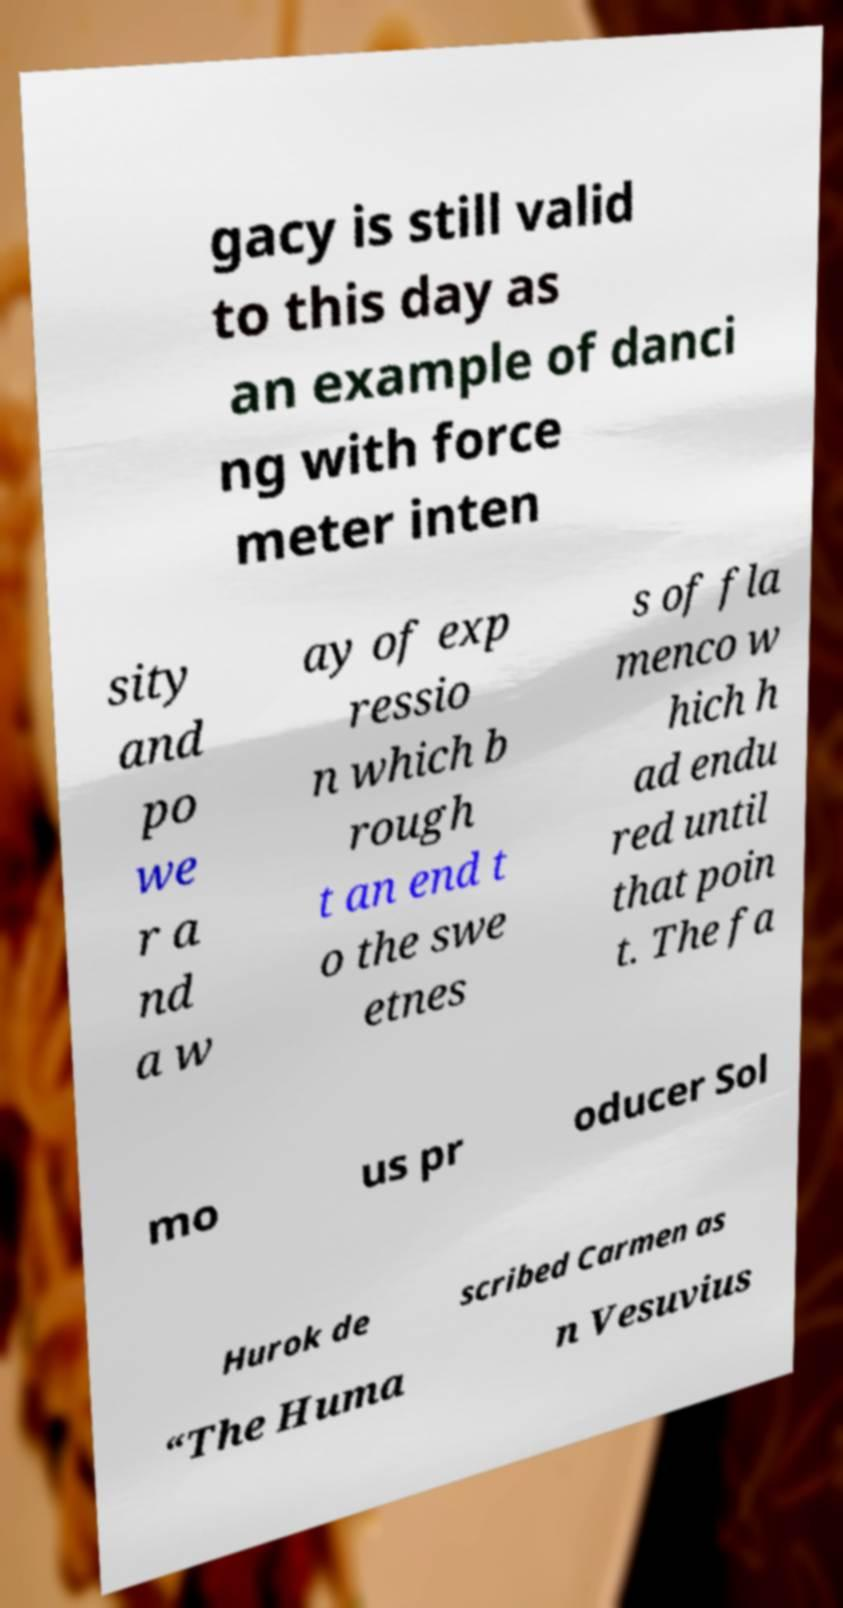There's text embedded in this image that I need extracted. Can you transcribe it verbatim? gacy is still valid to this day as an example of danci ng with force meter inten sity and po we r a nd a w ay of exp ressio n which b rough t an end t o the swe etnes s of fla menco w hich h ad endu red until that poin t. The fa mo us pr oducer Sol Hurok de scribed Carmen as “The Huma n Vesuvius 